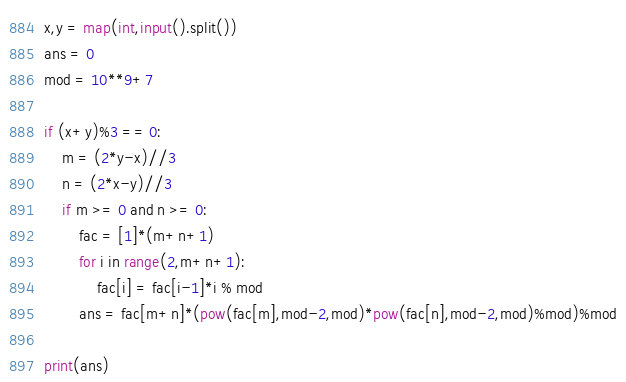<code> <loc_0><loc_0><loc_500><loc_500><_Python_>x,y = map(int,input().split())
ans = 0
mod = 10**9+7

if (x+y)%3 == 0:
    m = (2*y-x)//3
    n = (2*x-y)//3
    if m >= 0 and n >= 0:
        fac = [1]*(m+n+1)
        for i in range(2,m+n+1): 
            fac[i] = fac[i-1]*i % mod
        ans = fac[m+n]*(pow(fac[m],mod-2,mod)*pow(fac[n],mod-2,mod)%mod)%mod

print(ans)</code> 